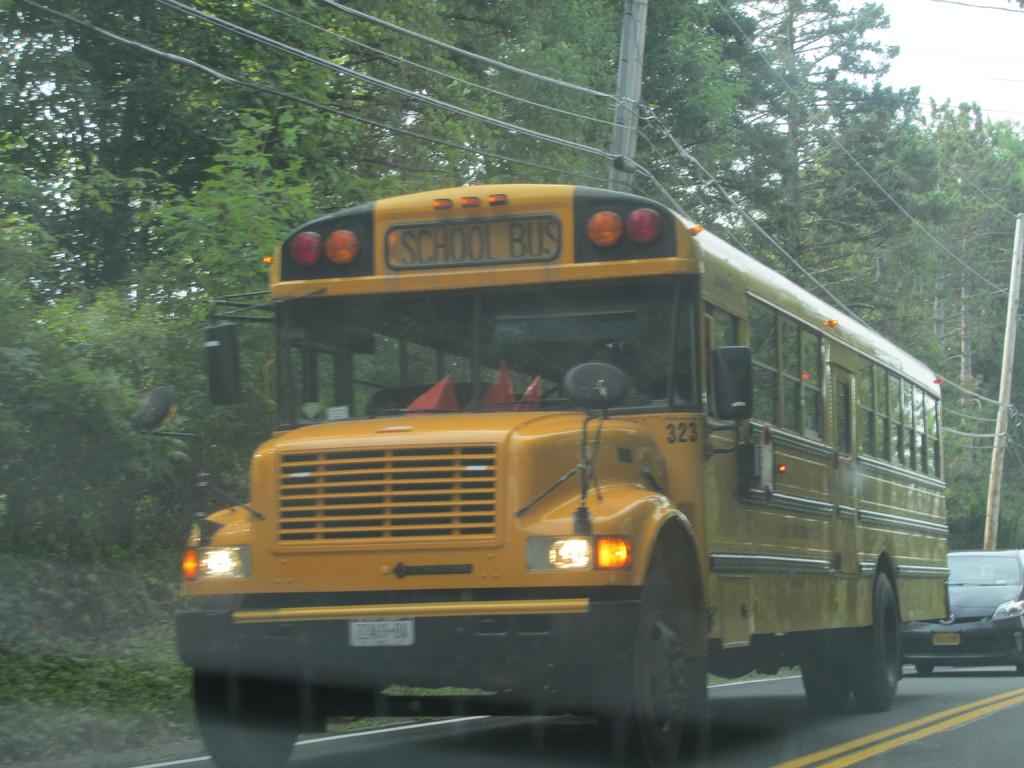<image>
Share a concise interpretation of the image provided. A classic American yellow schoolbus travels along a treelined road with a car not far behind it. 